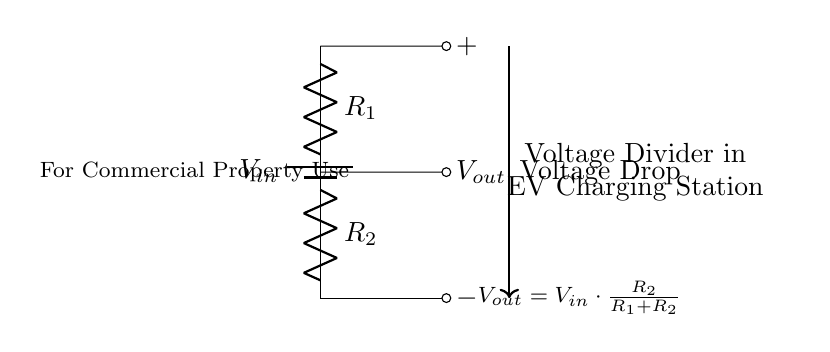What is the value of Vout? Vout is calculated using the formula given in the circuit diagram: Vout = Vin * (R2 / (R1 + R2)). Since the specific values for Vin, R1, and R2 are not provided, we can't assign a numerical answer.
Answer: Vout = Vin * (R2 / (R1 + R2)) What type of circuit is this? The circuit presented is a voltage divider, as indicated by the configuration of resistors R1 and R2. This type of circuit is explicitly used to divide input voltage into smaller output voltage.
Answer: Voltage divider What component does R2 represent? R2 serves as one of the resistive elements in the voltage divider circuit, and is responsible for determining the output voltage along with R1.
Answer: Resistor What happens to Vout if R1 is increased? If R1 is increased while R2 remains constant, the output voltage Vout decreases according to the voltage divider rule, since a larger R1 means less proportion of Vin is across R2.
Answer: Vout decreases What is the relationship between R1 and R2 for a maximum Vout? For maximum Vout, R2 should be significantly larger than R1, ideally approaching infinity, so that the majority of the input voltage appears across R2.
Answer: R2 > R1 What does the voltage drop represent in this circuit? The voltage drop represents the difference in electrical potential between the input voltage and the output voltage, governed by the values of R1 and R2, which affects how the total input voltage is divided.
Answer: Voltage difference 